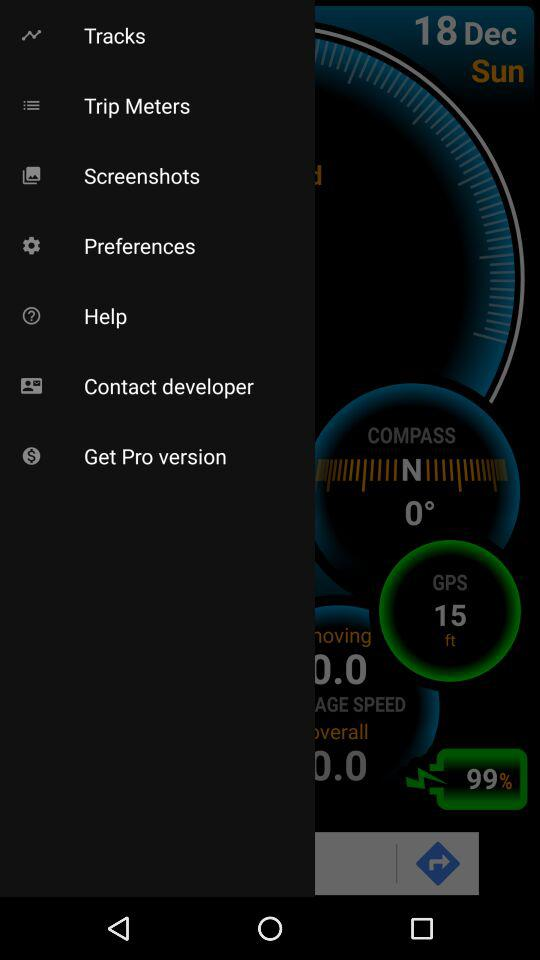How many degrees is the compass heading?
Answer the question using a single word or phrase. 0° 